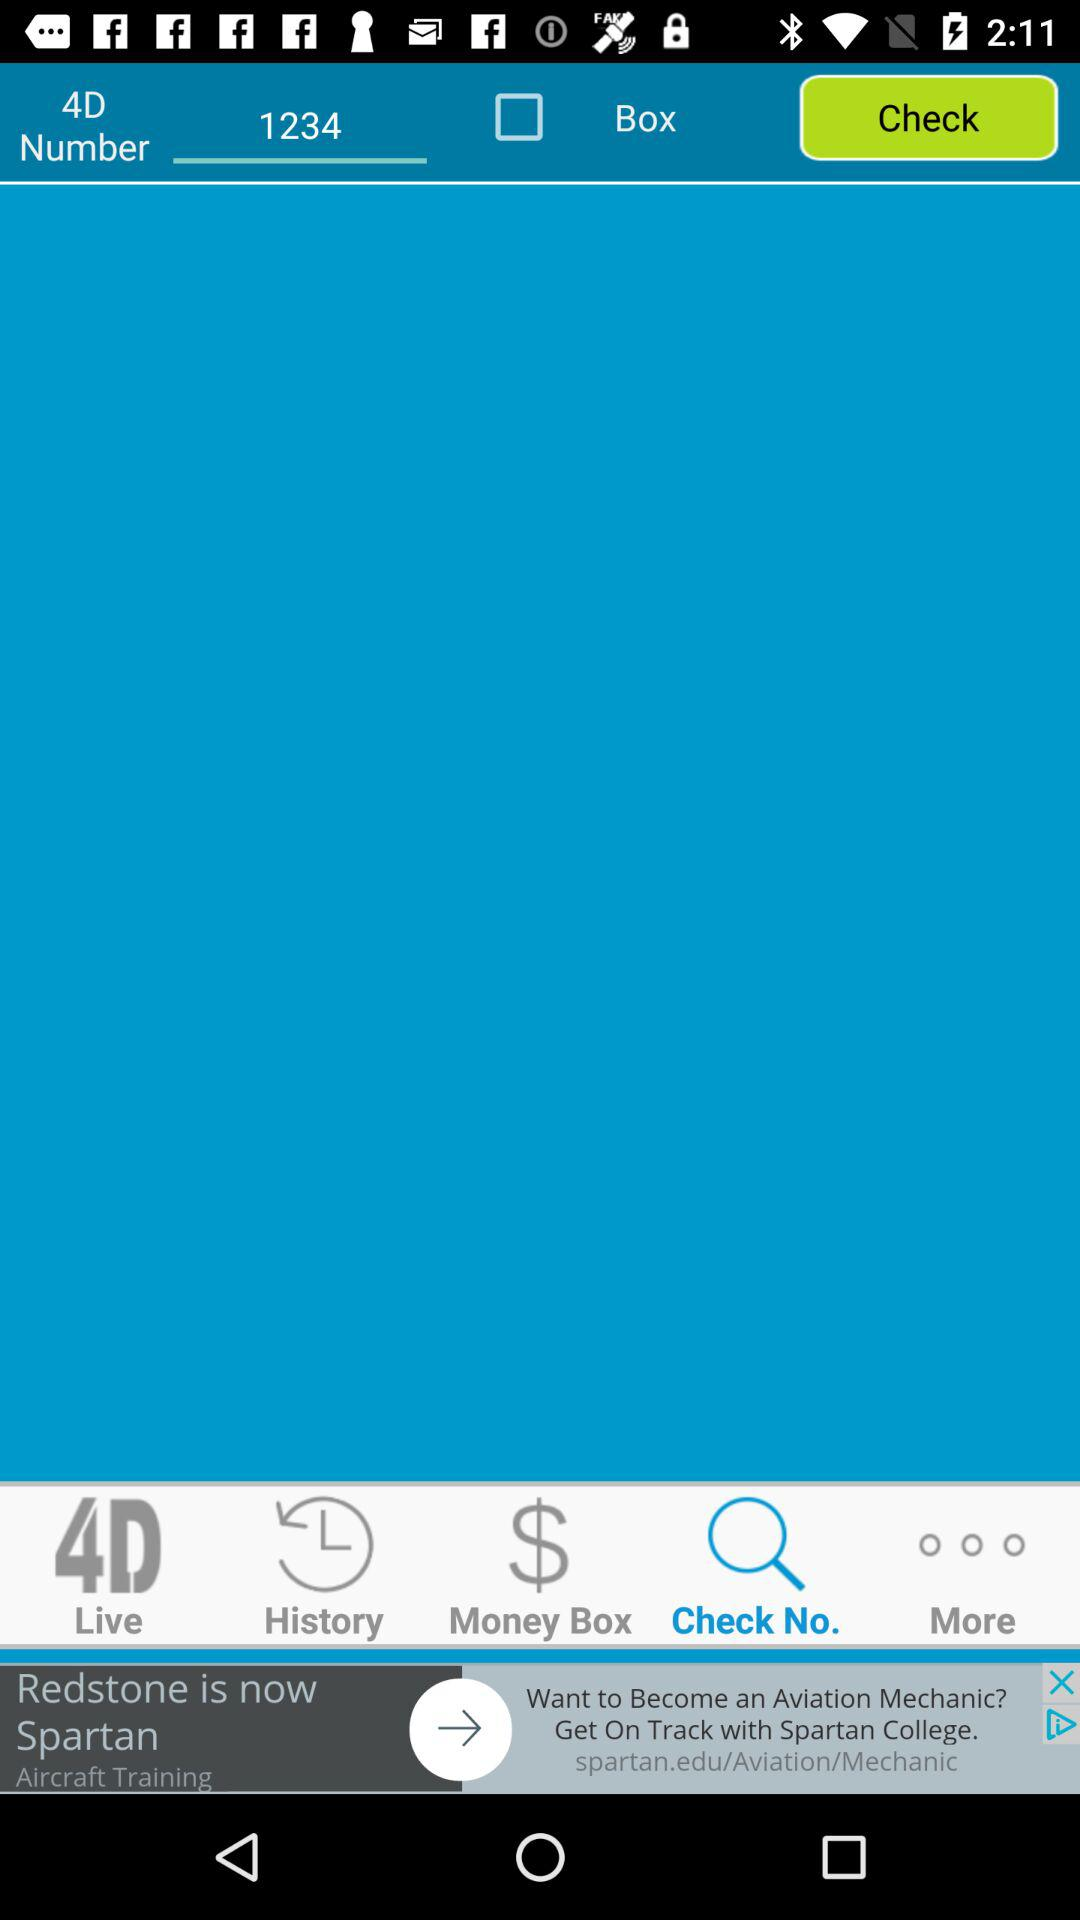Which tab is selected? The selected tab is "Check No.". 